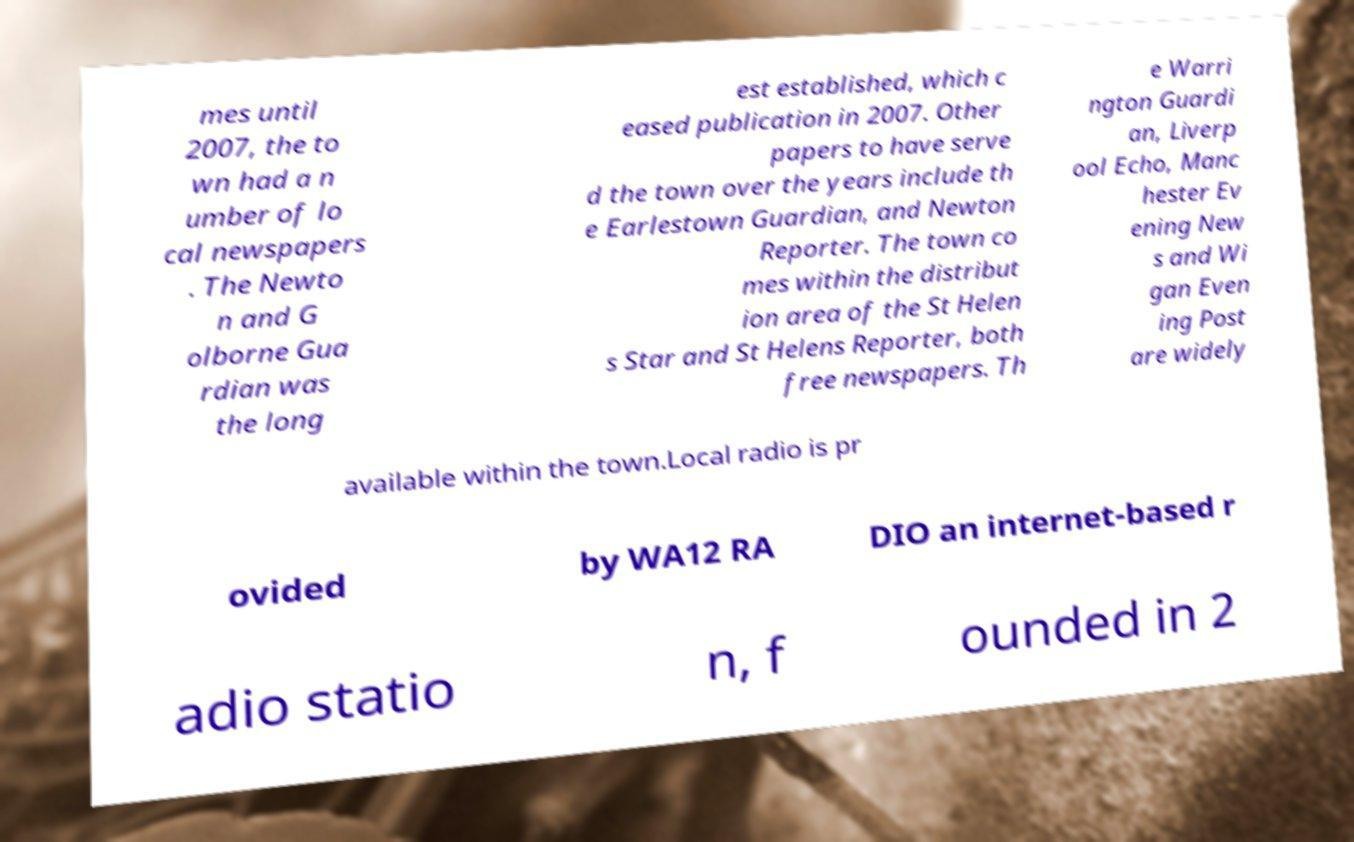Please identify and transcribe the text found in this image. mes until 2007, the to wn had a n umber of lo cal newspapers . The Newto n and G olborne Gua rdian was the long est established, which c eased publication in 2007. Other papers to have serve d the town over the years include th e Earlestown Guardian, and Newton Reporter. The town co mes within the distribut ion area of the St Helen s Star and St Helens Reporter, both free newspapers. Th e Warri ngton Guardi an, Liverp ool Echo, Manc hester Ev ening New s and Wi gan Even ing Post are widely available within the town.Local radio is pr ovided by WA12 RA DIO an internet-based r adio statio n, f ounded in 2 